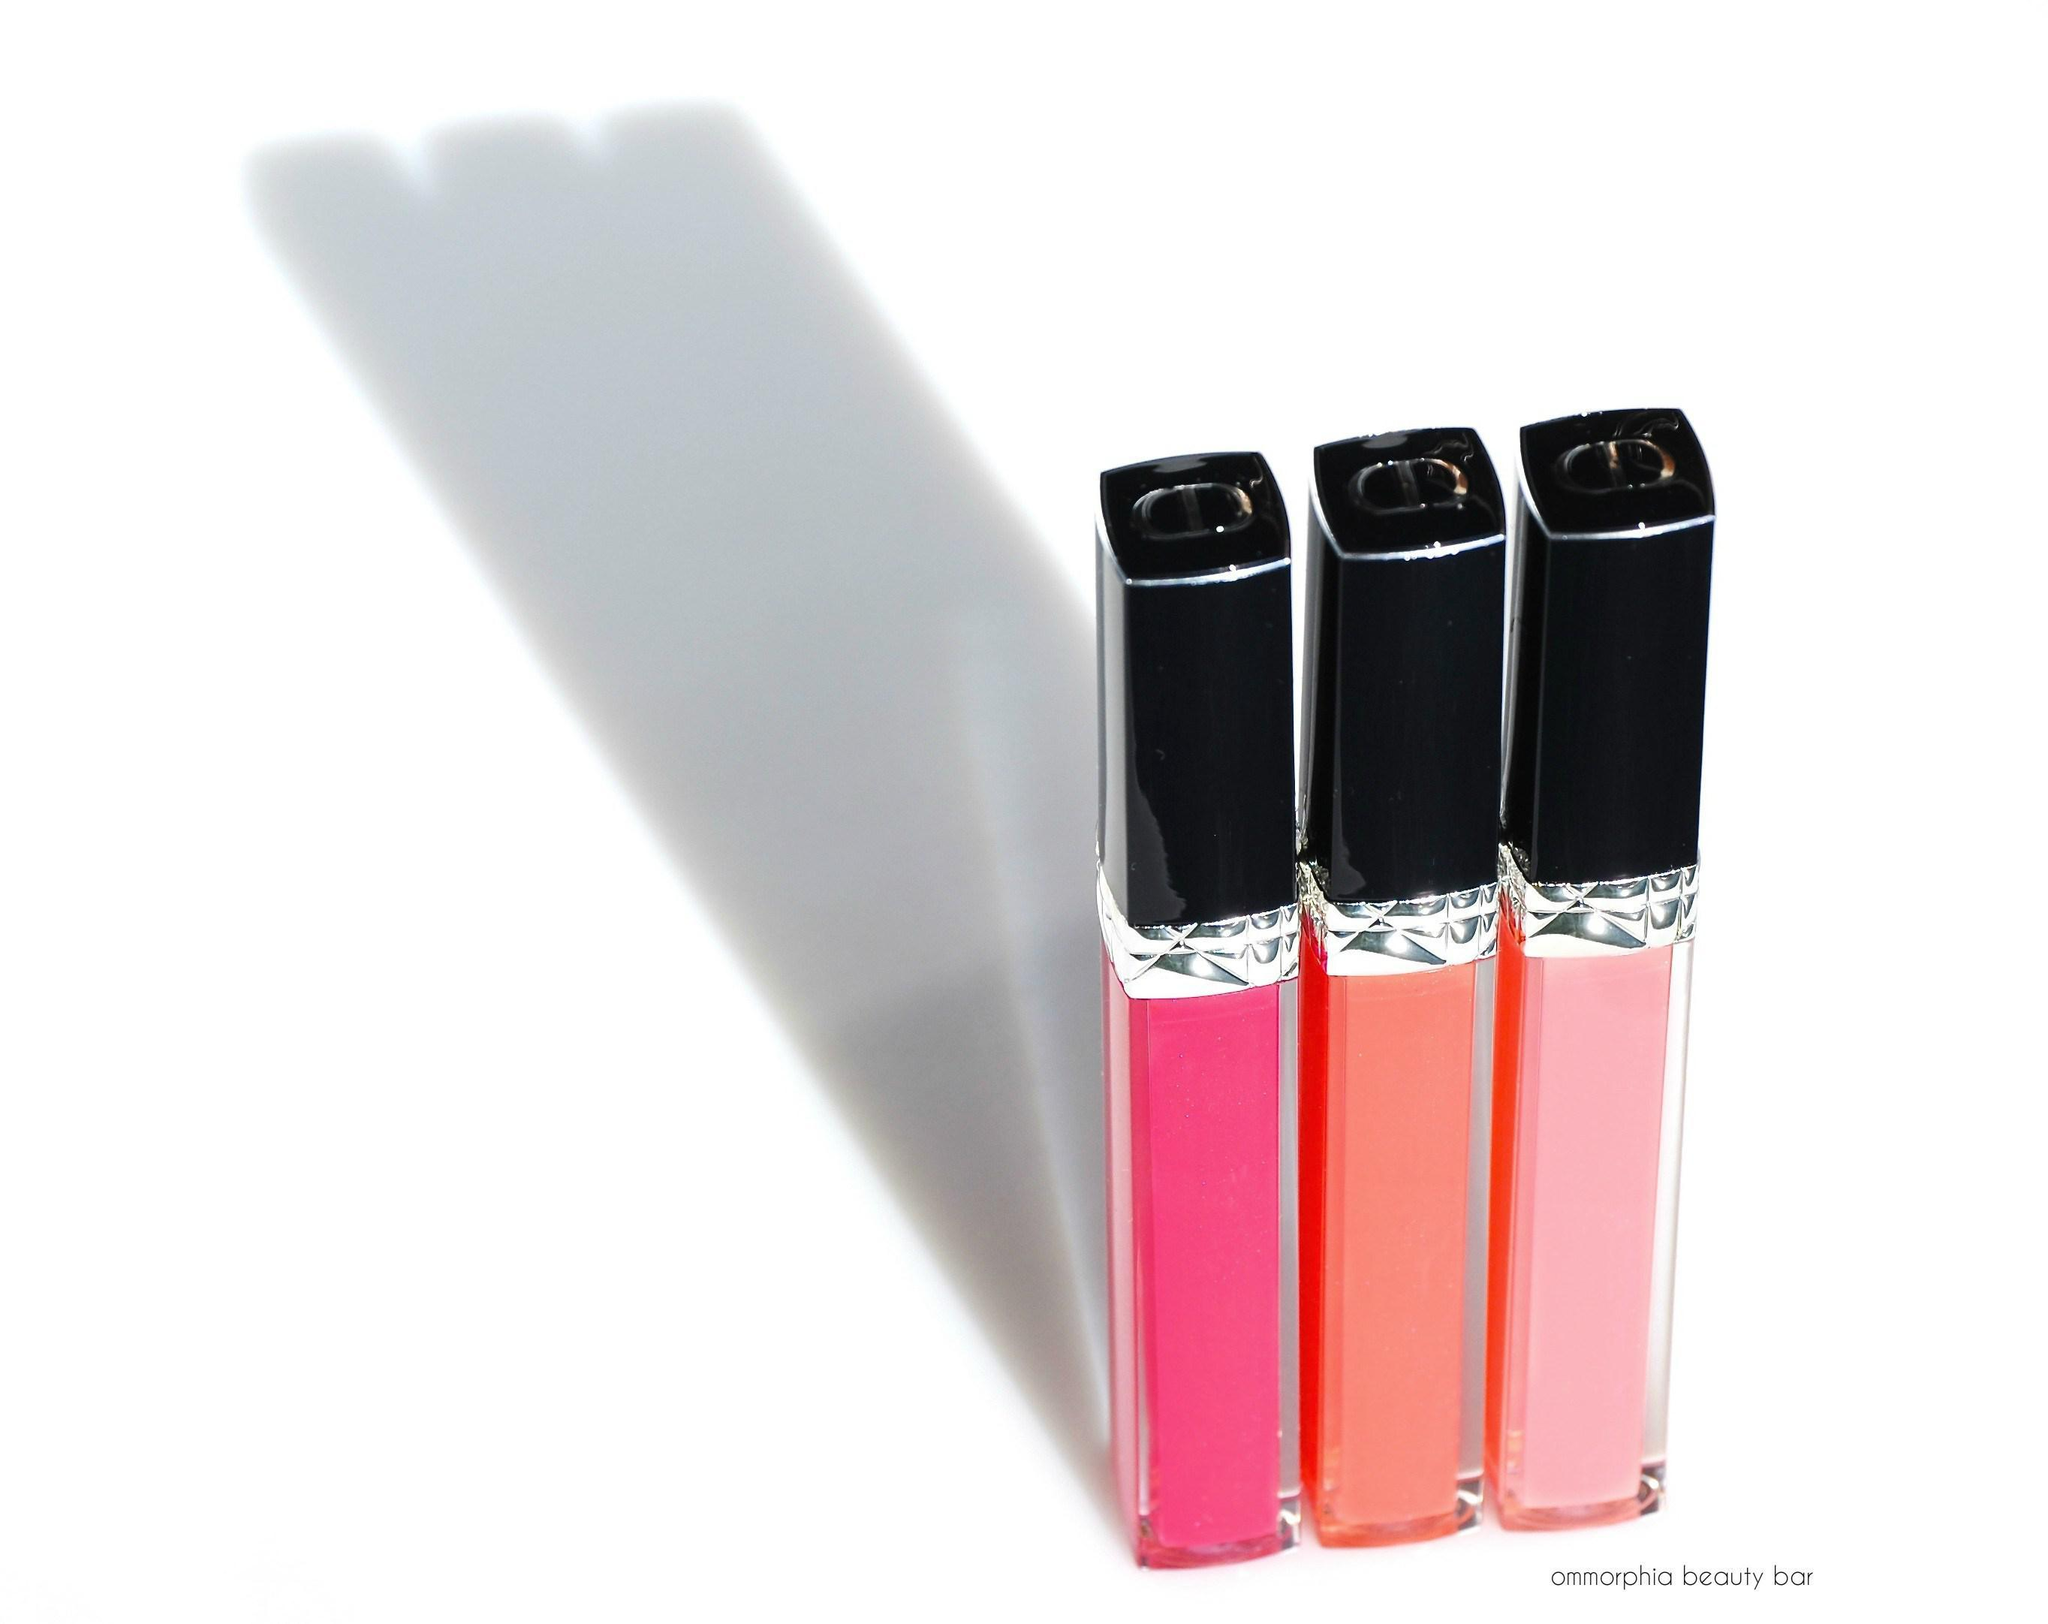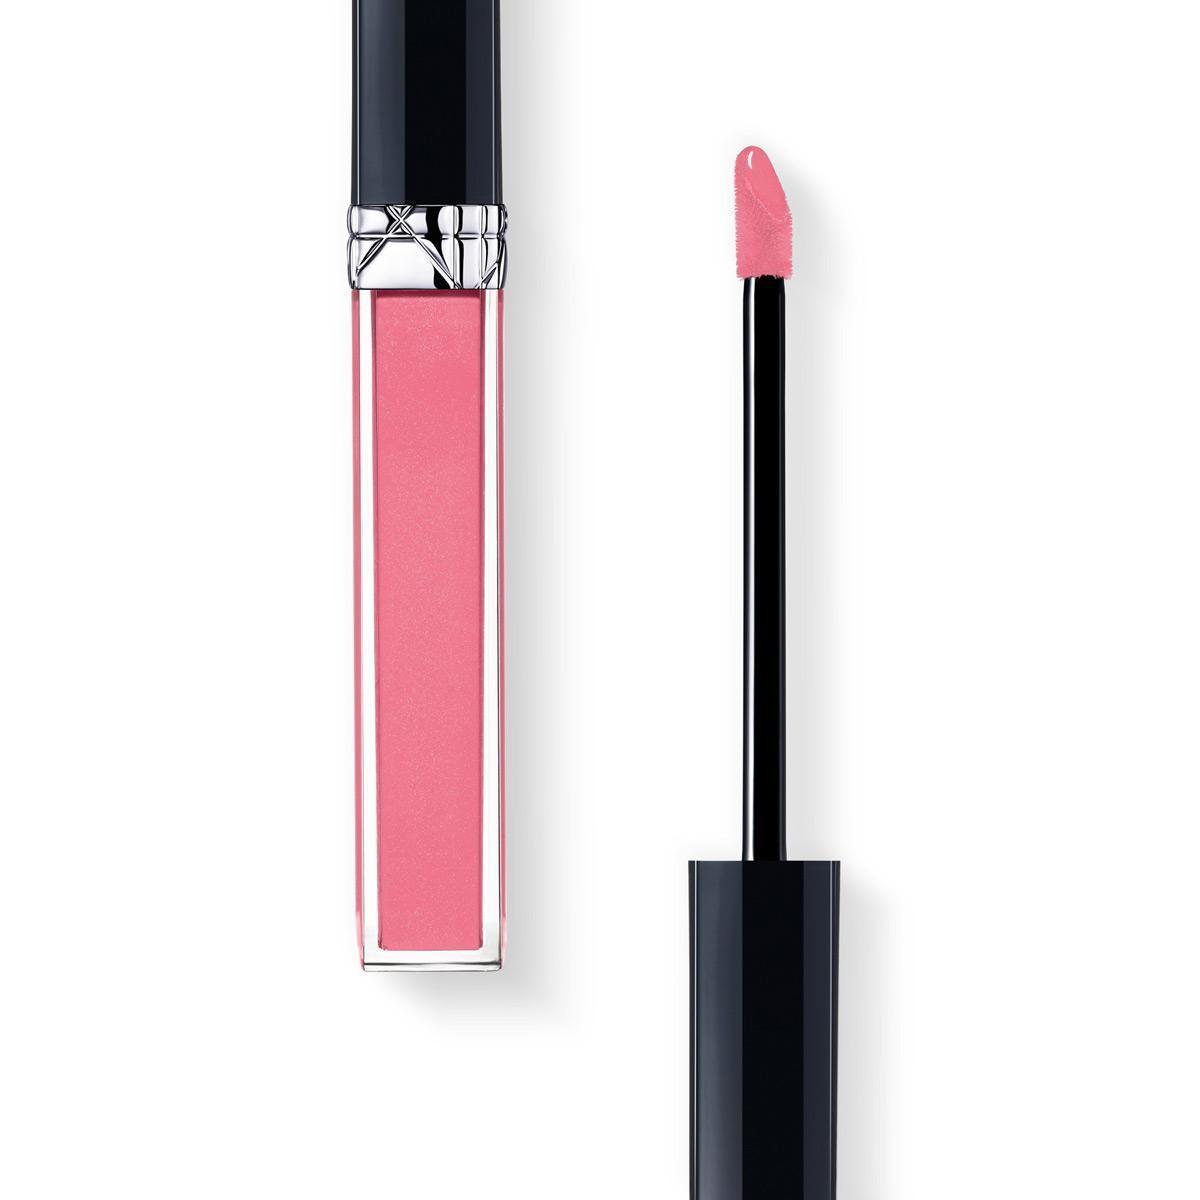The first image is the image on the left, the second image is the image on the right. Examine the images to the left and right. Is the description "In each picture, there is one lip gloss tube with a black lid and no label." accurate? Answer yes or no. No. The first image is the image on the left, the second image is the image on the right. Examine the images to the left and right. Is the description "There is at least one lip gloss applicator out of the tube." accurate? Answer yes or no. Yes. 